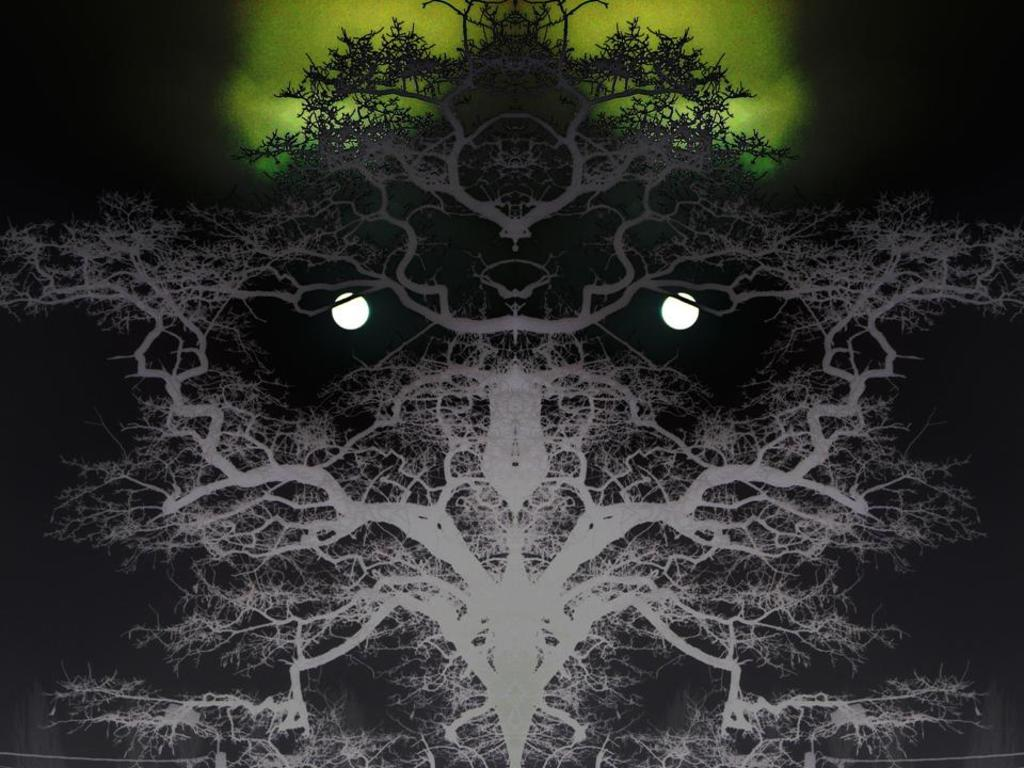What type of reflection is shown in the image? The image contains a mirror image. What natural elements can be seen in the mirror image? Trees and the moon are visible in the mirror image. What color is the object in the mirror image? The object in the mirror image is green. What part of the image appears to be dark? The top right corner of the image appears to be dark. What type of animal can be heard singing in the image? There is no animal or song present in the image; it is a still image with a mirror reflection. 